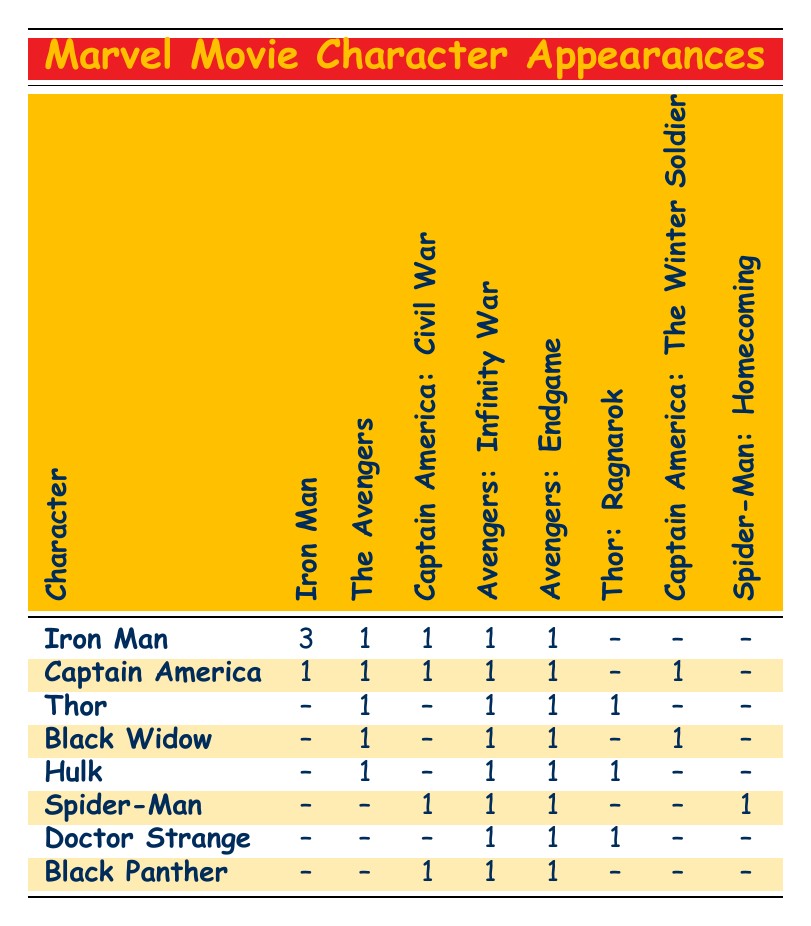What is the total number of appearances for Iron Man in all films listed? Adding the values for Iron Man across the films results in 3 (Iron Man) + 1 (The Avengers) + 1 (Captain America: Civil War) + 1 (Avengers: Infinity War) + 1 (Avengers: Endgame) = 7.
Answer: 7 How many films did Captain America appear in? By counting the values under Captain America, he appears in 1 (Iron Man) + 1 (The Avengers) + 1 (Captain America: The First Avenger) + 1 (Captain America: The Winter Soldier) + 1 (Captain America: Civil War) + 1 (Avengers: Infinity War) + 1 (Avengers: Endgame) = 7 films.
Answer: 7 Did Black Widow appear in any of the Captain America films? Checking Black Widow's appearances, she is listed under Captain America: The Winter Soldier, confirming she appeared in that film.
Answer: Yes Which character has the most appearances in the Marvel films listed? The table shows Iron Man with the highest appearance count at 3. No other character had a number equal to or greater than this.
Answer: Iron Man How many characters appeared in Avengers: Infinity War? To find the total characters, we add up appearances in Avengers: Infinity War: Iron Man (1) + Captain America (1) + Thor (1) + Black Widow (1) + Hulk (1) + Spider-Man (1) + Doctor Strange (1) + Black Panther (1). This gives us a total of 8 characters.
Answer: 8 Did Thor appear in a movie without Captain America? Thor appeared in Thor: The Dark World and Thor: Ragnarok, which do not feature Captain America. Therefore, he did appear in movies without Captain America.
Answer: Yes What is the average number of appearances for the characters in the films listed? First, we need to sum all character appearances: Iron Man (7) + Captain America (7) + Thor (6) + Black Widow (5) + Hulk (5) + Spider-Man (4) + Doctor Strange (3) + Black Panther (3) = 40 appearances. There are 8 characters, so the average is 40 / 8 = 5.
Answer: 5 In how many films did Hulk appear? The values show Hulk appeared in 1 (The Incredible Hulk) + 1 (The Avengers) + 1 (Avengers: Age of Ultron) + 1 (Thor: Ragnarok) + 1 (Avengers: Infinity War) + 1 (Avengers: Endgame) = 6 films.
Answer: 6 Which character appears in the most films after Iron Man? After Iron Man, both Captain America and Thor appear in 7 films each, making them tied for the most appearances after Iron Man.
Answer: Captain America, Thor 